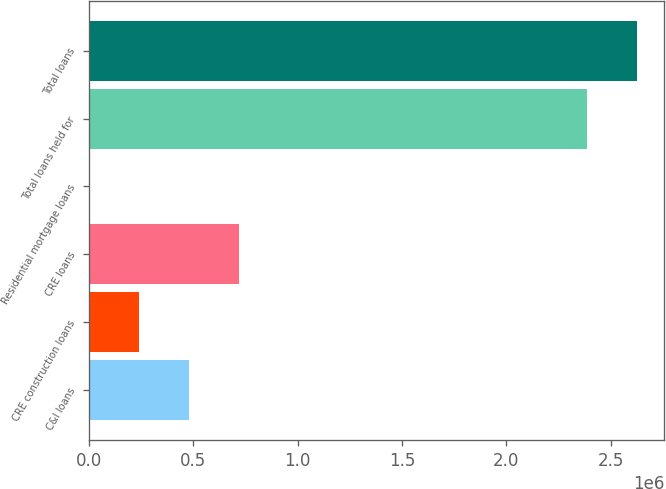Convert chart to OTSL. <chart><loc_0><loc_0><loc_500><loc_500><bar_chart><fcel>C&I loans<fcel>CRE construction loans<fcel>CRE loans<fcel>Residential mortgage loans<fcel>Total loans held for<fcel>Total loans<nl><fcel>478494<fcel>240047<fcel>716941<fcel>1600<fcel>2.38607e+06<fcel>2.62452e+06<nl></chart> 